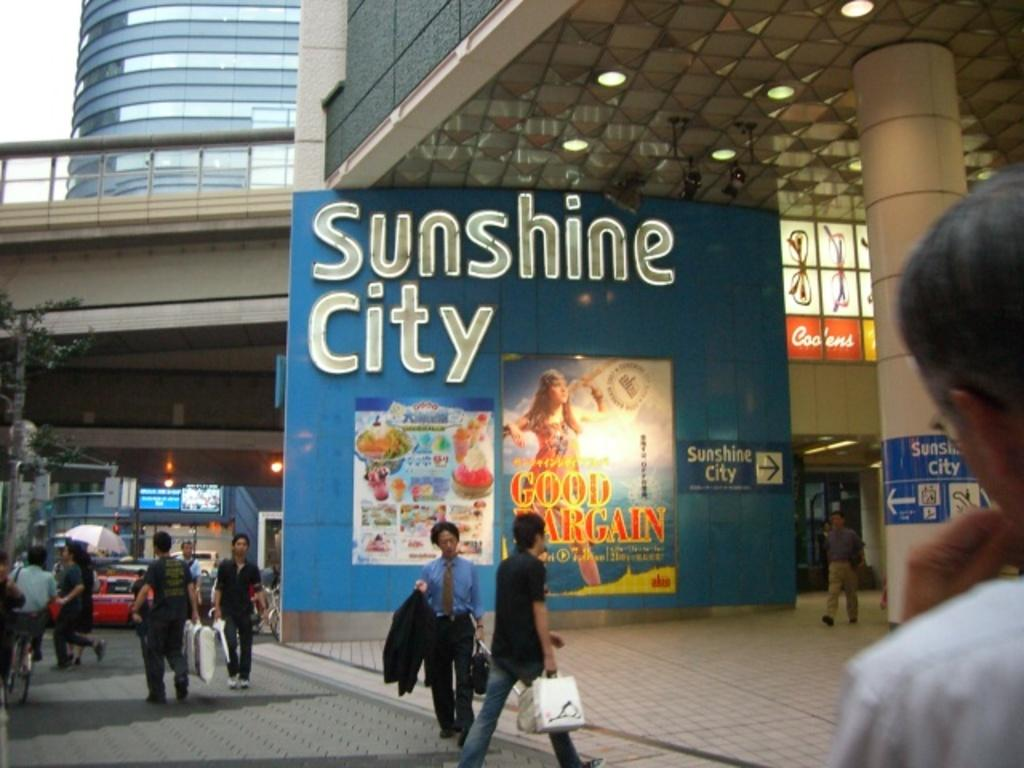<image>
Give a short and clear explanation of the subsequent image. A Sunshine city sign with advertisements with people walking around it. 